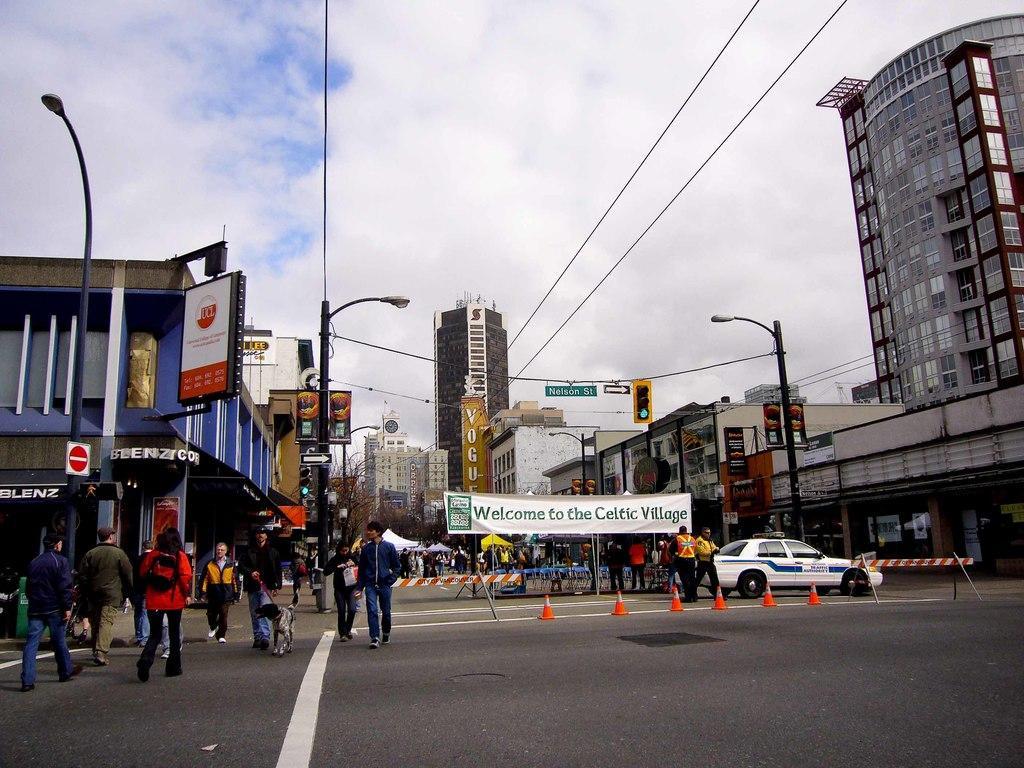In one or two sentences, can you explain what this image depicts? In this image we can see the buildings. On few buildings we can see some text. In front of the buildings we can see the trees, stalls and persons. In the foreground we can see street poles with lights, wires, persons, banners with text, traffic light, a car and barriers. On the left side, we can see boards attached to a building. On the boards we can see the text. We can see the person's, a street pole and a dog. At the top we can see the sky. 